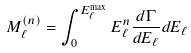<formula> <loc_0><loc_0><loc_500><loc_500>M _ { \ell } ^ { ( n ) } = \int _ { 0 } ^ { E _ { \ell } ^ { \max } } E _ { \ell } ^ { n } { \frac { d \Gamma } { d E _ { \ell } } } d E _ { \ell }</formula> 